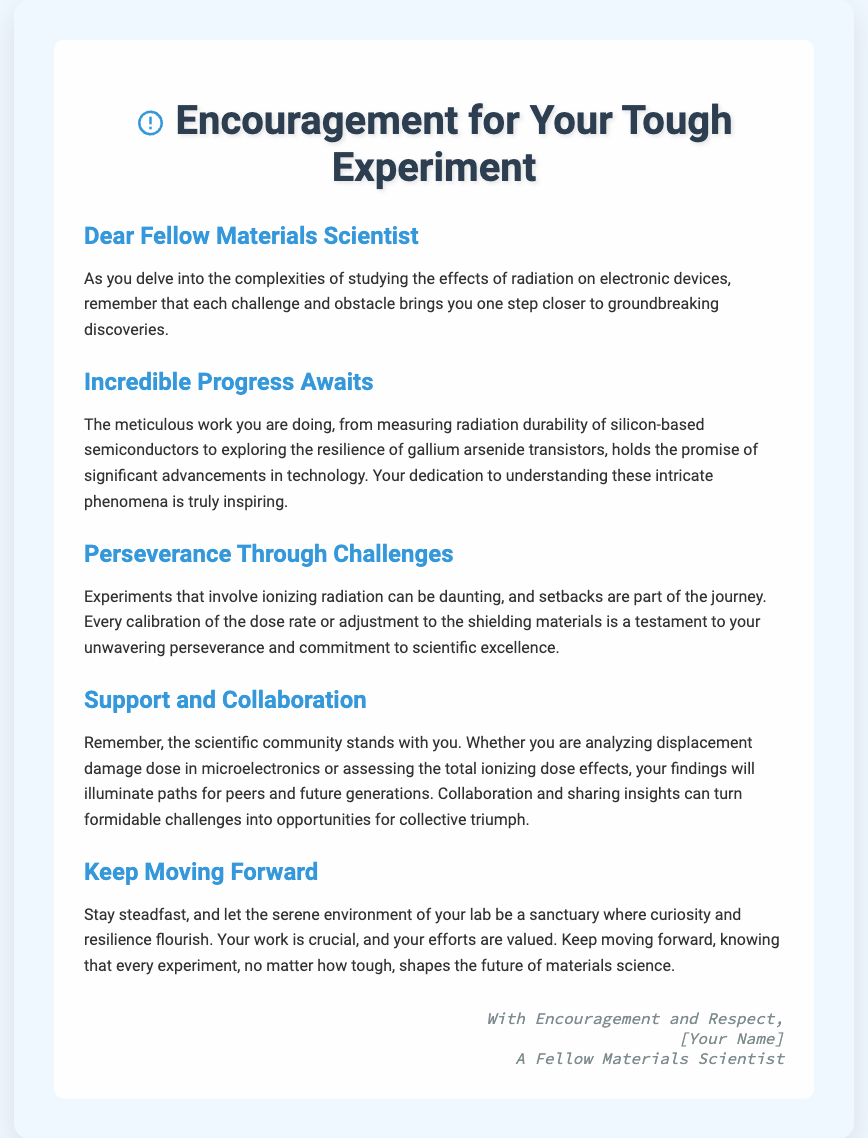What is the main theme of the card? The theme is centered around providing encouragement during challenging experimental phases in materials science.
Answer: Encouragement for Your Tough Experiment Who is the intended recipient of the card? The card is addressed to fellow materials scientists, indicating it is meant for individuals in that field.
Answer: Dear Fellow Materials Scientist What type of experiments are referenced in the card? The card refers to experiments involving the effects of radiation on electronic devices.
Answer: Effects of radiation on electronic devices What materials are mentioned in relation to radiation durability? Specific materials mentioned include silicon-based semiconductors and gallium arsenide transistors.
Answer: Silicon-based semiconductors, gallium arsenide transistors What does the card encourage recipients to do during challenges? The card encourages recipients to stay steadfast and keep moving forward in their research despite difficulties.
Answer: Keep moving forward In which section is the importance of collaboration highlighted? The importance of collaboration is emphasized in the section titled "Support and Collaboration."
Answer: Support and Collaboration What colored tones are used in the card's design? The card features calm blue and green tones to create a serene background.
Answer: Blue and green Who signs off the card? The card is signed off by the sender, identifying themselves as a fellow materials scientist.
Answer: [Your Name], A Fellow Materials Scientist 